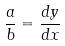<formula> <loc_0><loc_0><loc_500><loc_500>\frac { a } { b } = \frac { d y } { d x }</formula> 